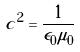Convert formula to latex. <formula><loc_0><loc_0><loc_500><loc_500>c ^ { 2 } = \frac { 1 } { \epsilon _ { 0 } \mu _ { 0 } }</formula> 